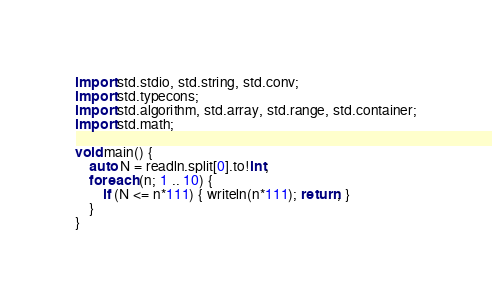Convert code to text. <code><loc_0><loc_0><loc_500><loc_500><_D_>import std.stdio, std.string, std.conv;
import std.typecons;
import std.algorithm, std.array, std.range, std.container;
import std.math;

void main() {
	auto N = readln.split[0].to!int;
	foreach (n; 1 .. 10) {
		if (N <= n*111) { writeln(n*111); return; }
	}
}</code> 